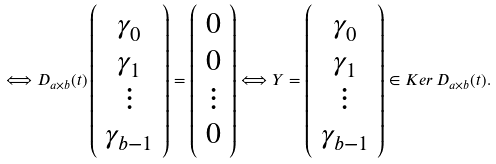Convert formula to latex. <formula><loc_0><loc_0><loc_500><loc_500>\Longleftrightarrow D _ { a \times b } ( t ) \left ( \begin{array} { c } \gamma _ { 0 } \\ \gamma _ { 1 } \\ \vdots \\ \gamma _ { b - 1 } \\ \end{array} \right ) = \left ( \begin{array} { c } 0 \\ 0 \\ \vdots \\ 0 \\ \end{array} \right ) \Longleftrightarrow Y = \left ( \begin{array} { c } \gamma _ { 0 } \\ \gamma _ { 1 } \\ \vdots \\ \gamma _ { b - 1 } \\ \end{array} \right ) \in K e r \, D _ { a \times b } ( t ) .</formula> 